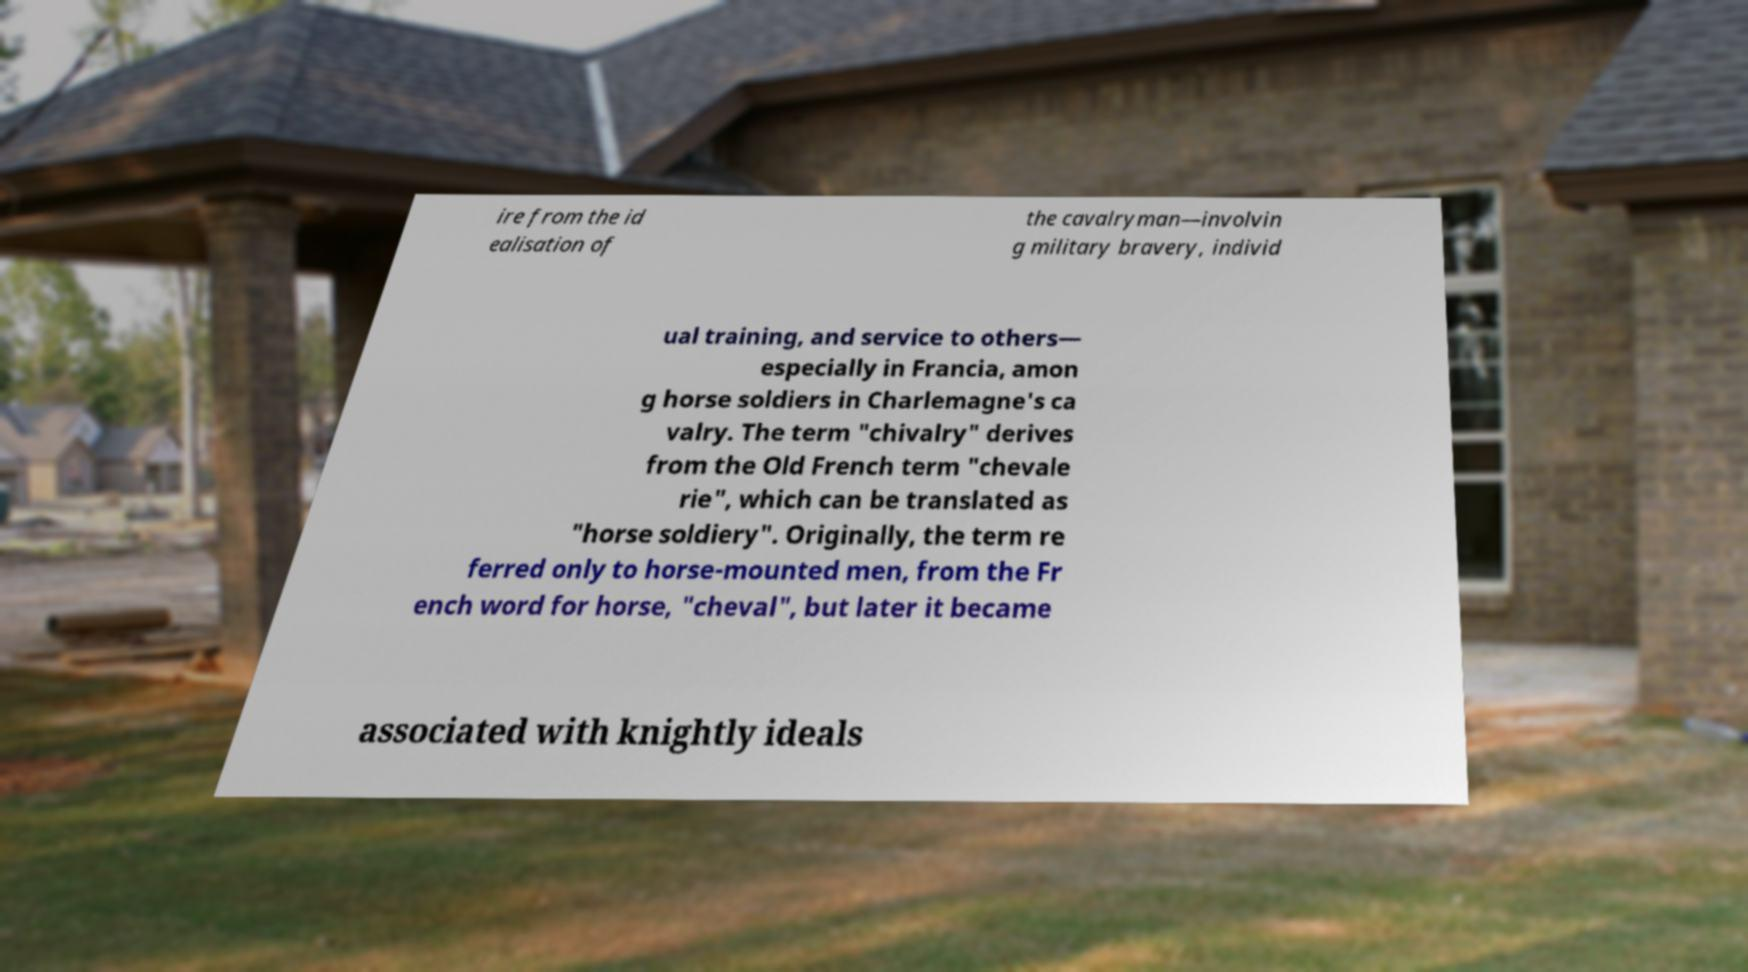Could you extract and type out the text from this image? ire from the id ealisation of the cavalryman—involvin g military bravery, individ ual training, and service to others— especially in Francia, amon g horse soldiers in Charlemagne's ca valry. The term "chivalry" derives from the Old French term "chevale rie", which can be translated as "horse soldiery". Originally, the term re ferred only to horse-mounted men, from the Fr ench word for horse, "cheval", but later it became associated with knightly ideals 